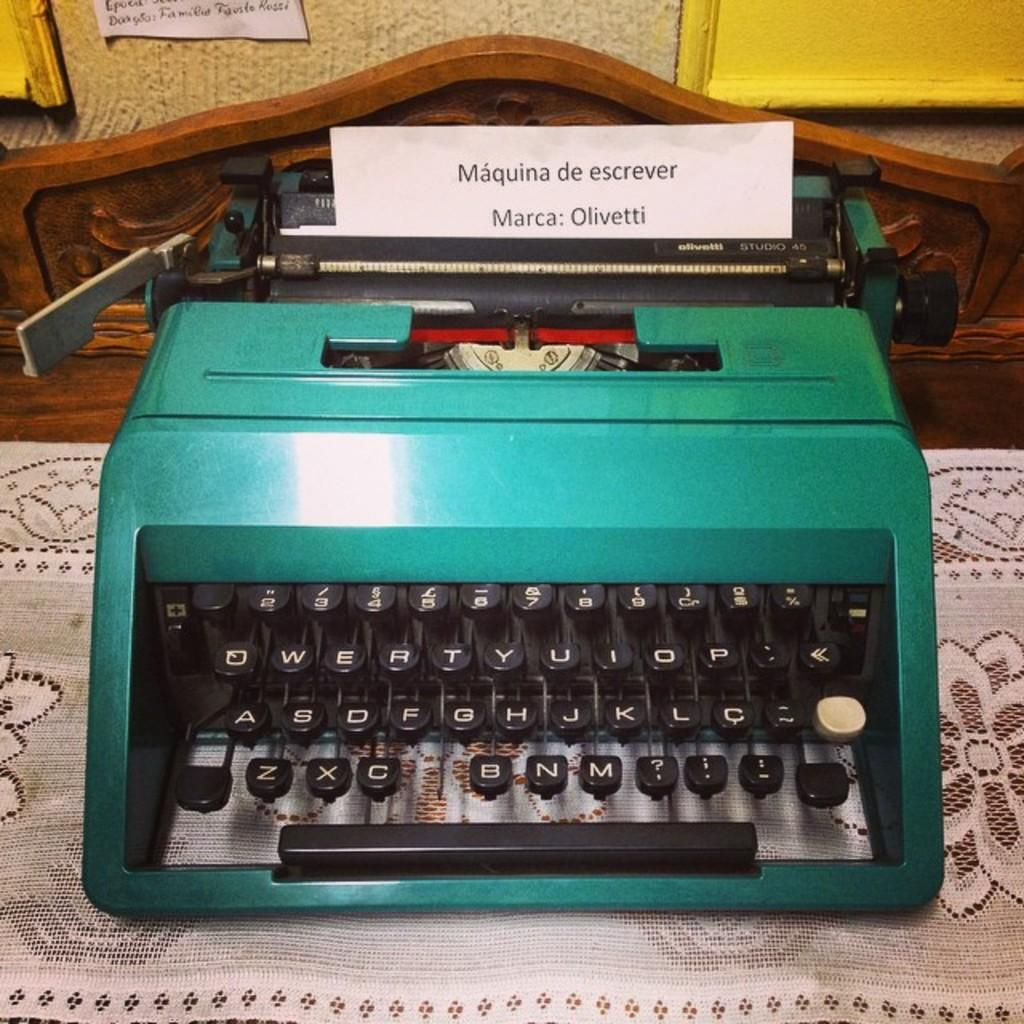<image>
Summarize the visual content of the image. A teal typewriter has a piece of paper in the top that says, "Marca: Olivetti" on it. 